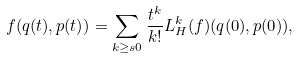Convert formula to latex. <formula><loc_0><loc_0><loc_500><loc_500>f ( q ( t ) , p ( t ) ) = \sum _ { k \geq s 0 } \frac { t ^ { k } } { k ! } L ^ { k } _ { H } ( f ) ( q ( 0 ) , p ( 0 ) ) ,</formula> 